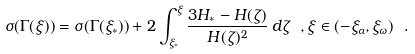Convert formula to latex. <formula><loc_0><loc_0><loc_500><loc_500>\sigma ( \Gamma ( \xi ) ) = \sigma ( \Gamma ( \xi _ { * } ) ) + 2 \int _ { \xi _ { * } } ^ { \xi } \frac { 3 H _ { * } - H ( \zeta ) } { H ( \zeta ) ^ { 2 } } \, d \zeta \ , \xi \in ( - \xi _ { \alpha } , \xi _ { \omega } ) \ .</formula> 